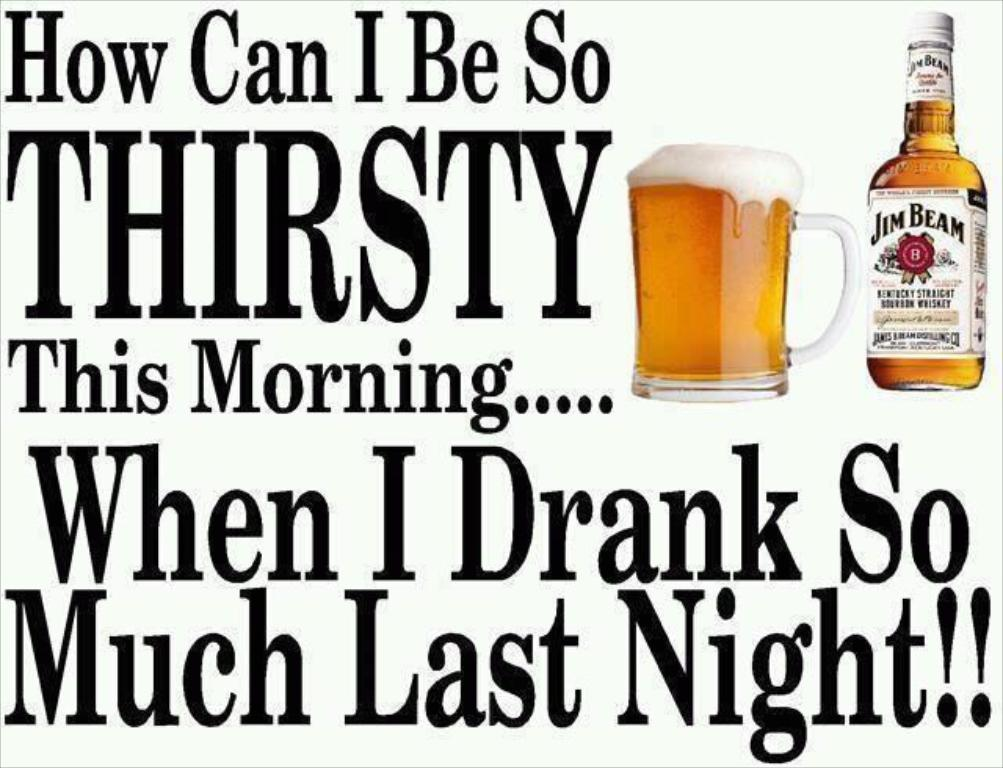<image>
Present a compact description of the photo's key features. An advertisement for Jim Beam starts with the phrase "How can I be so thirsty this morning..." 